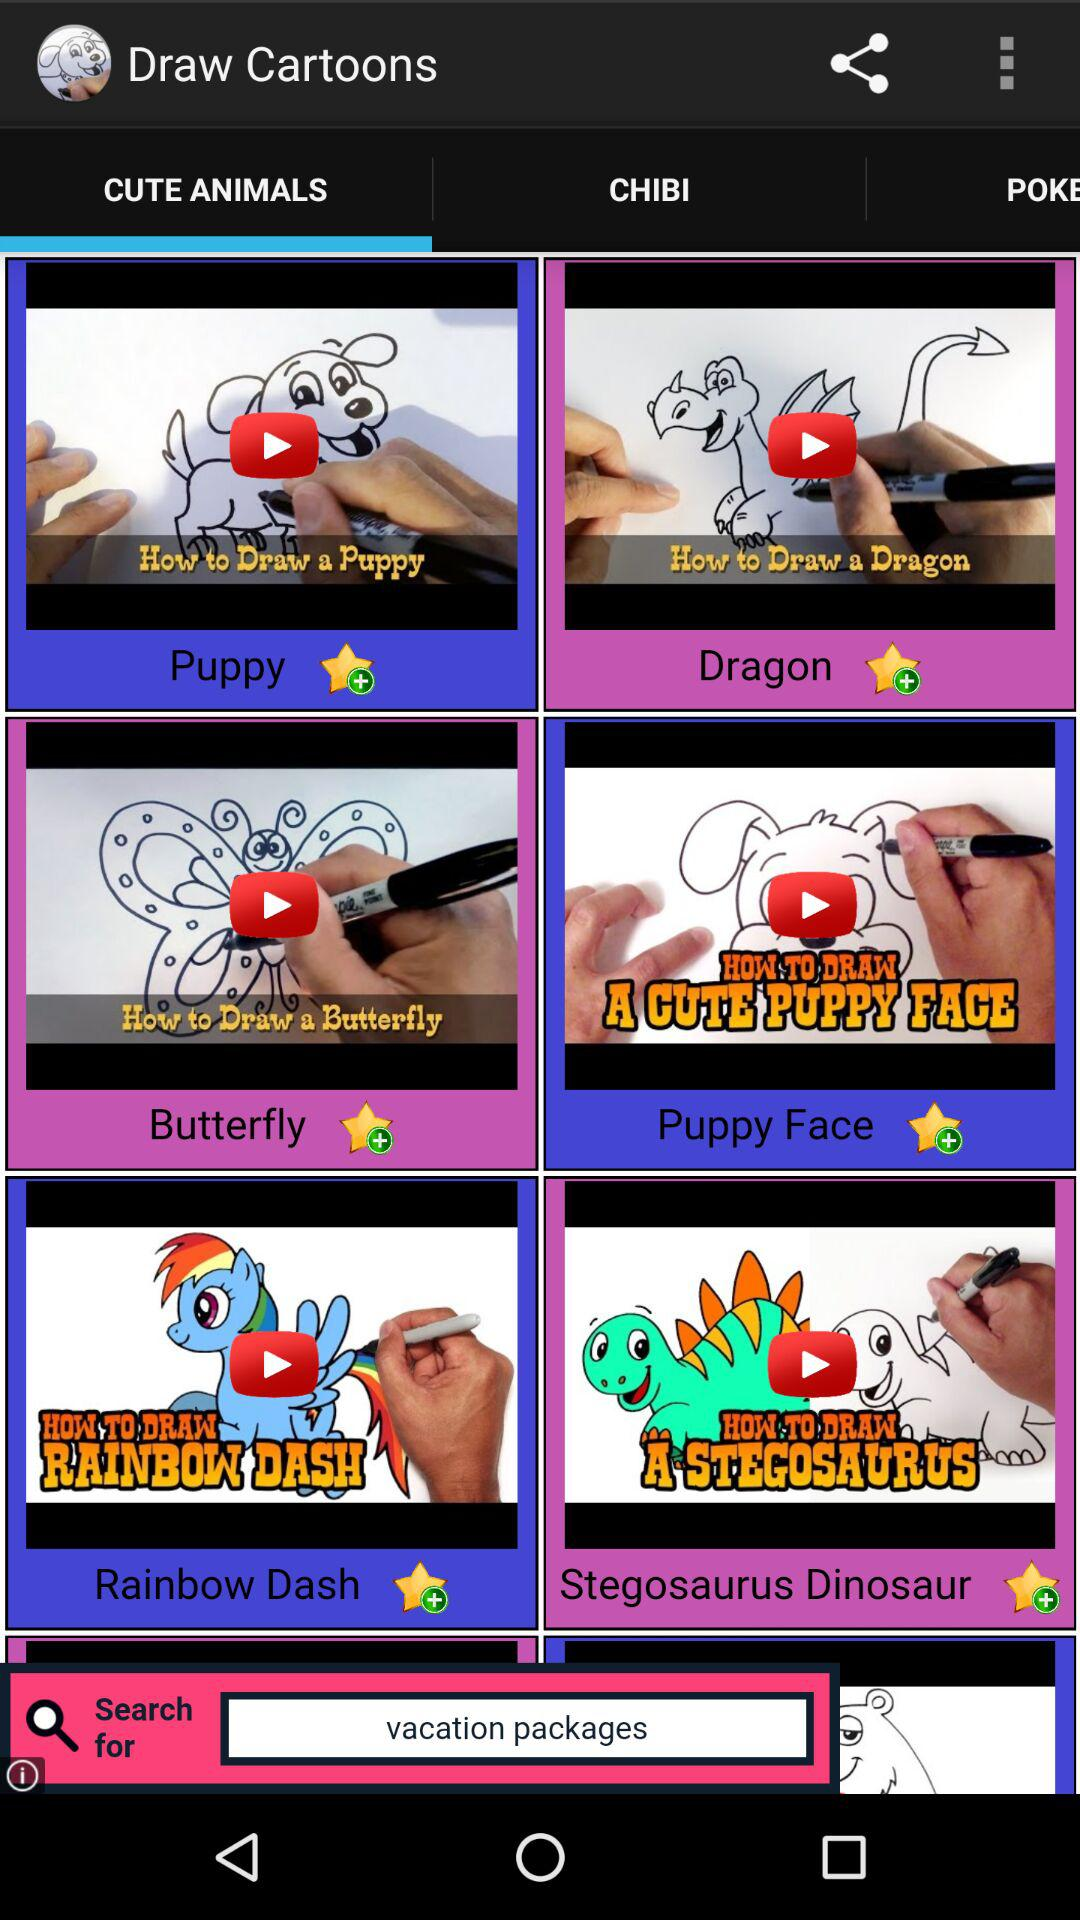Which tab am I using? You are using the tab "CUTE ANIMALS". 